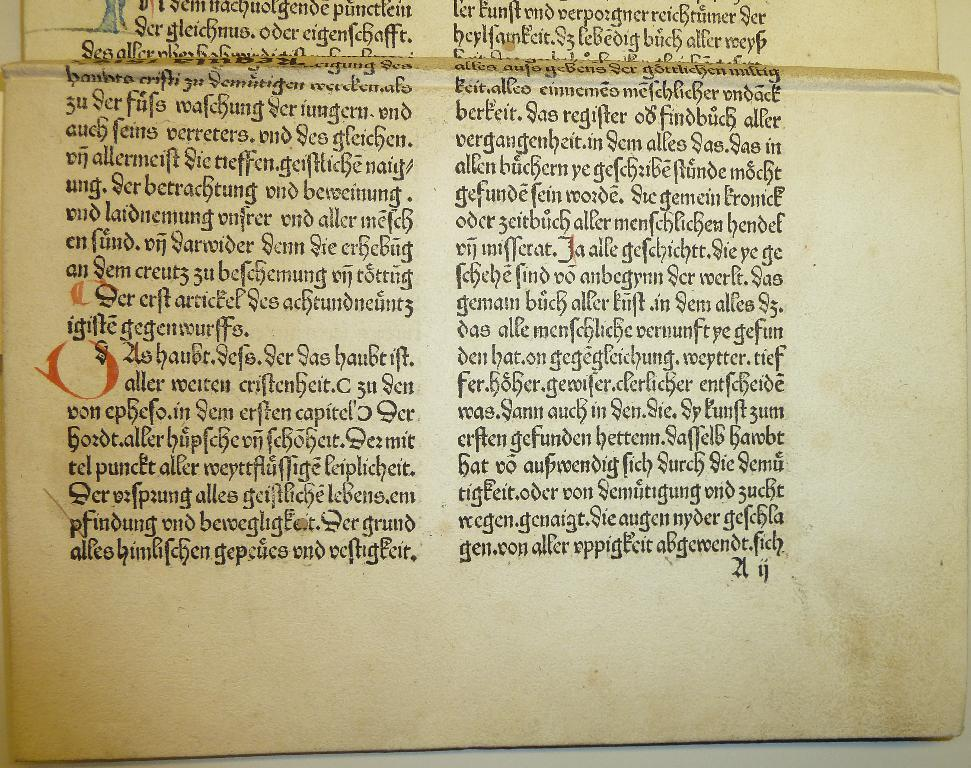<image>
Present a compact description of the photo's key features. A page has old German script on it, with a red mark below the words Der erst artickel. 